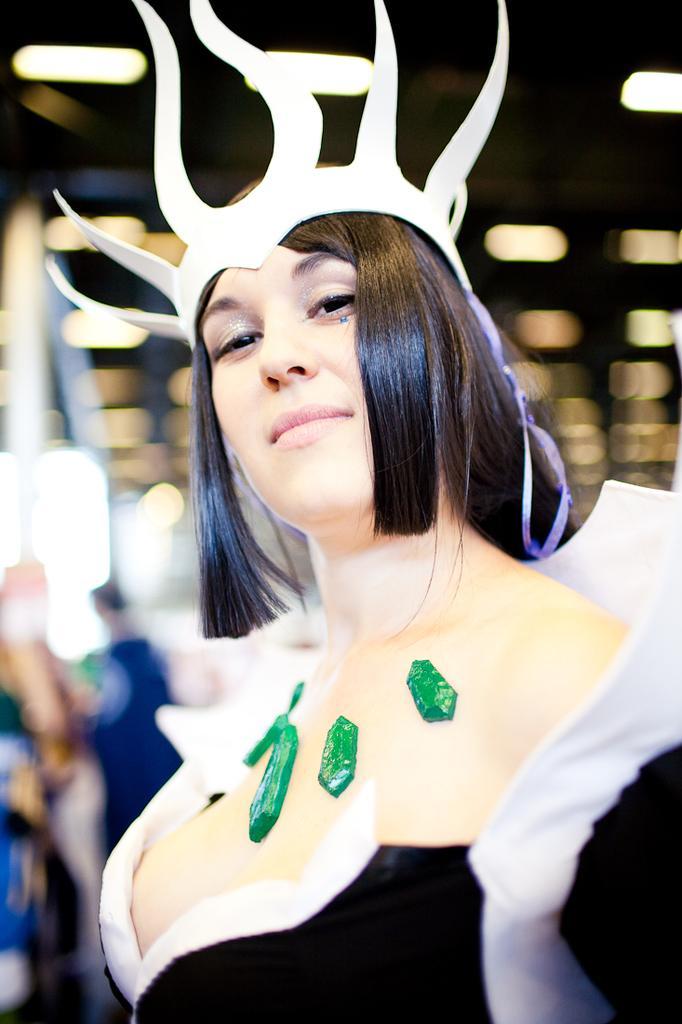Describe this image in one or two sentences. In this image there is one women is standing in middle of this image and wearing a white color object, and there is a wall in the background. There are some persons standing on the left side of this image. 